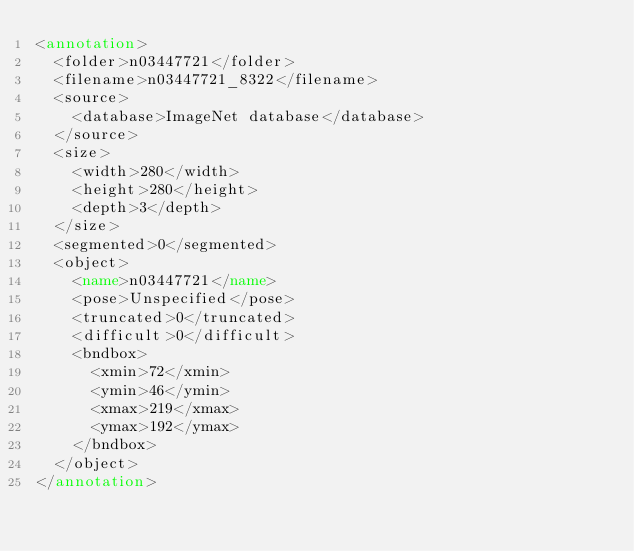<code> <loc_0><loc_0><loc_500><loc_500><_XML_><annotation>
	<folder>n03447721</folder>
	<filename>n03447721_8322</filename>
	<source>
		<database>ImageNet database</database>
	</source>
	<size>
		<width>280</width>
		<height>280</height>
		<depth>3</depth>
	</size>
	<segmented>0</segmented>
	<object>
		<name>n03447721</name>
		<pose>Unspecified</pose>
		<truncated>0</truncated>
		<difficult>0</difficult>
		<bndbox>
			<xmin>72</xmin>
			<ymin>46</ymin>
			<xmax>219</xmax>
			<ymax>192</ymax>
		</bndbox>
	</object>
</annotation></code> 